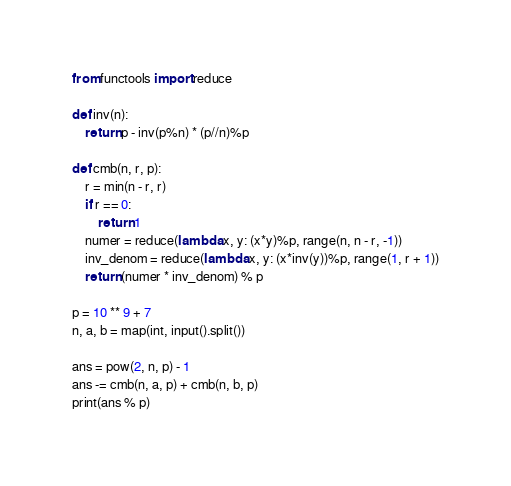<code> <loc_0><loc_0><loc_500><loc_500><_Python_>from functools import reduce

def inv(n):
    return p - inv(p%n) * (p//n)%p

def cmb(n, r, p):
    r = min(n - r, r)
    if r == 0:
        return 1
    numer = reduce(lambda x, y: (x*y)%p, range(n, n - r, -1))
    inv_denom = reduce(lambda x, y: (x*inv(y))%p, range(1, r + 1))
    return (numer * inv_denom) % p

p = 10 ** 9 + 7
n, a, b = map(int, input().split())

ans = pow(2, n, p) - 1
ans -= cmb(n, a, p) + cmb(n, b, p)
print(ans % p)
</code> 